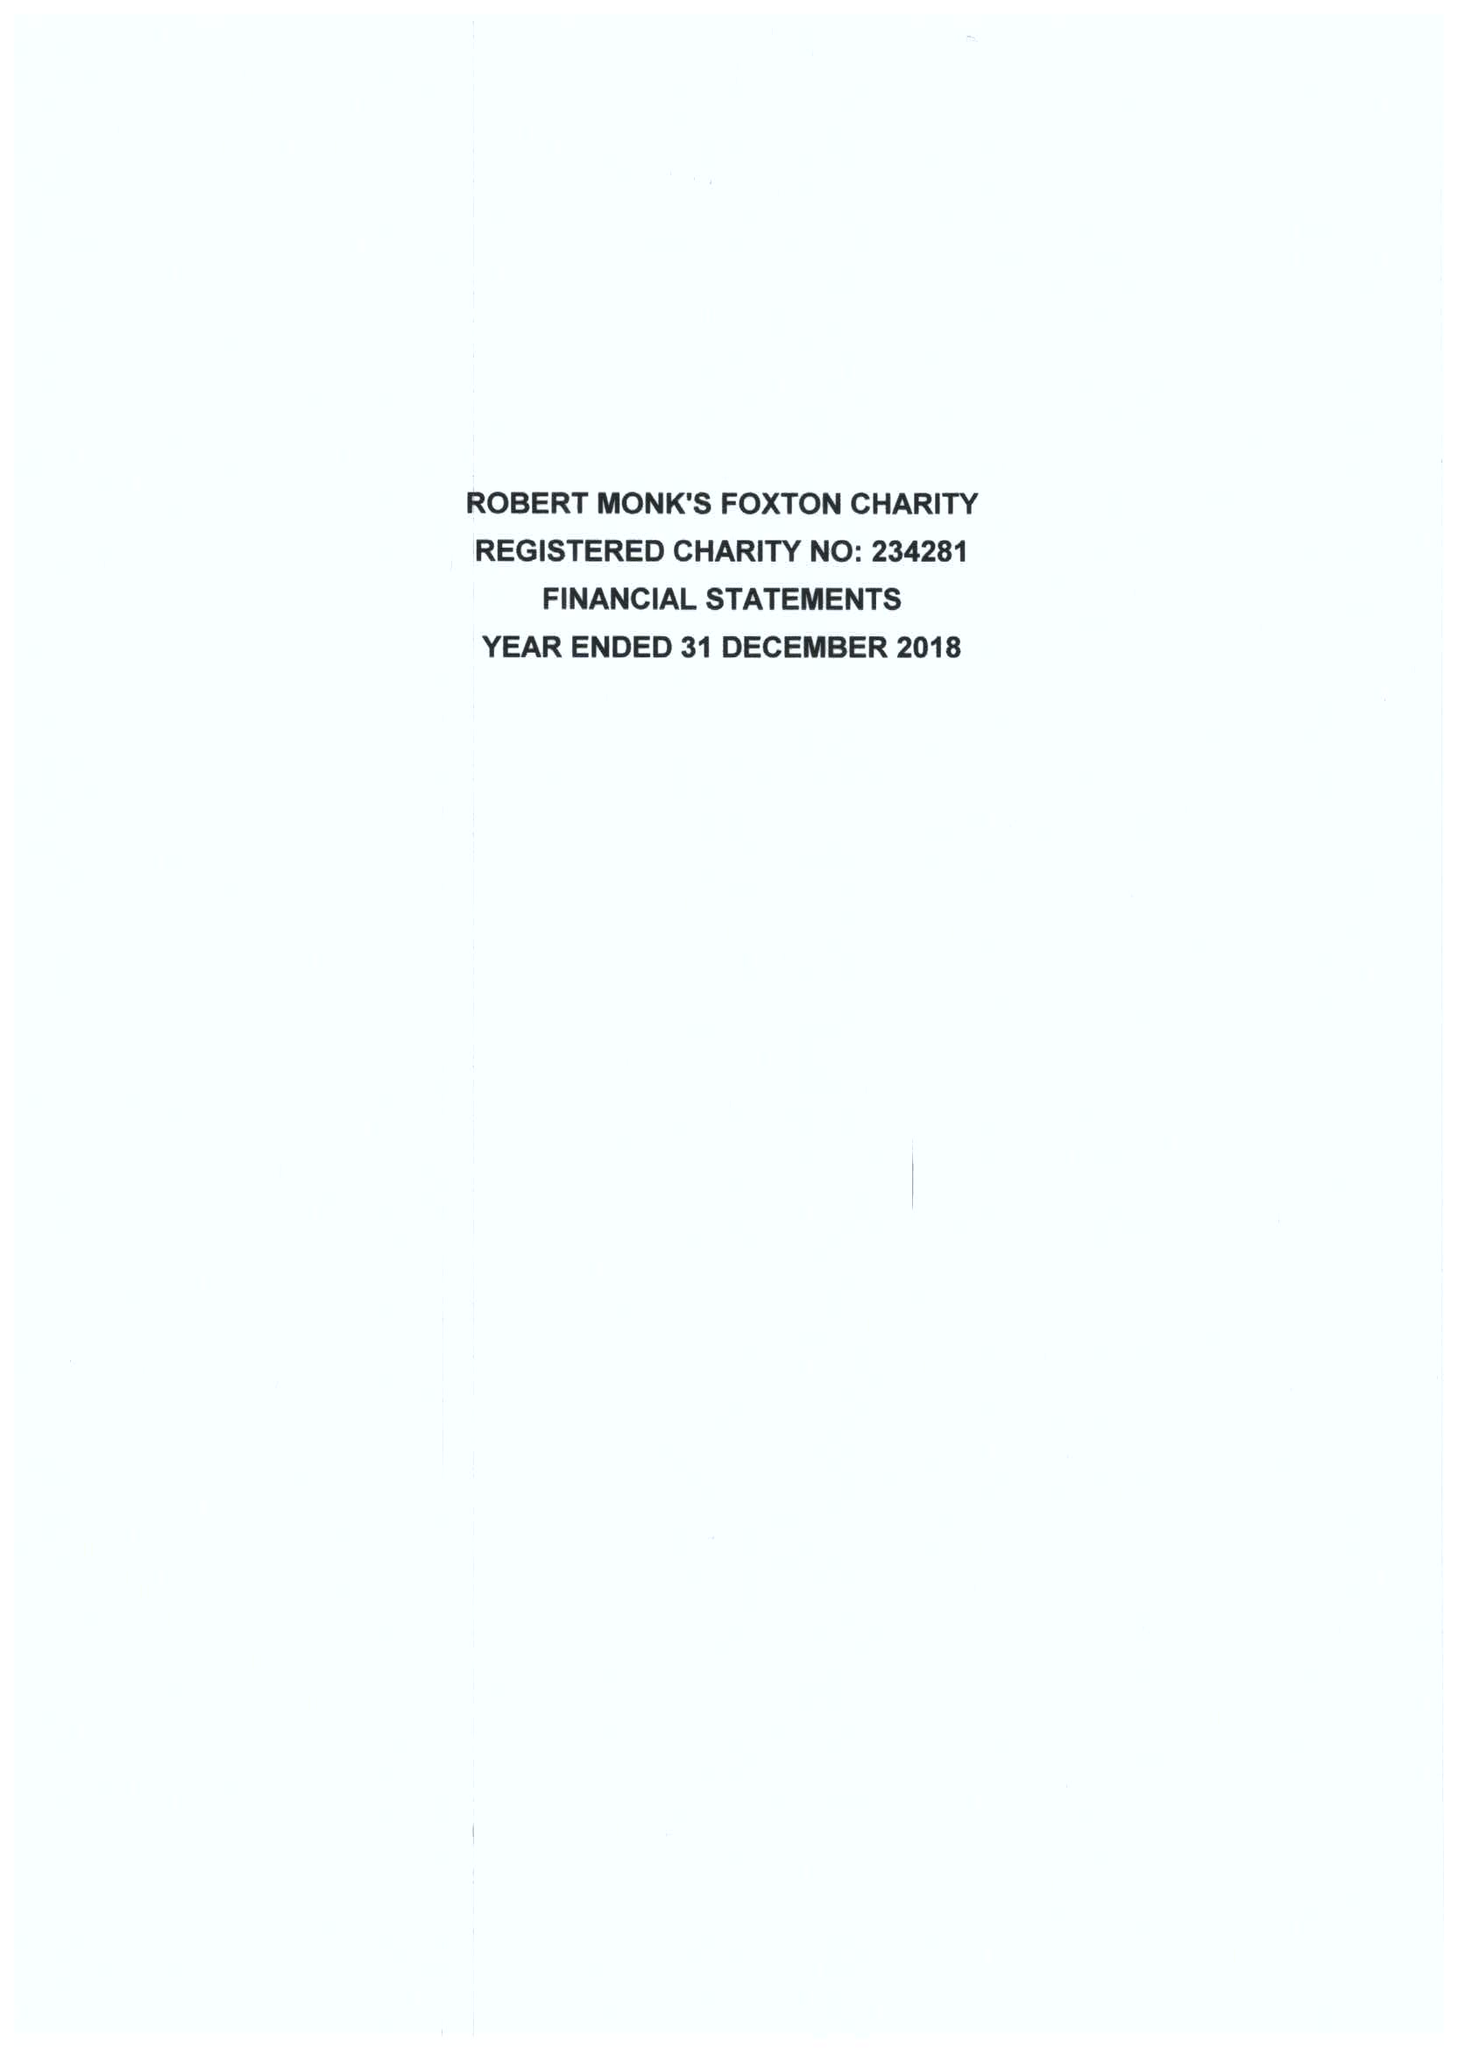What is the value for the charity_name?
Answer the question using a single word or phrase. Robert Monks Foxton Charity 